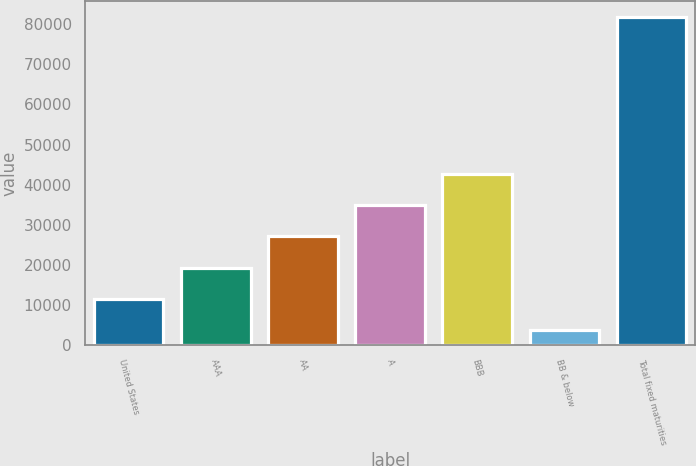<chart> <loc_0><loc_0><loc_500><loc_500><bar_chart><fcel>United States<fcel>AAA<fcel>AA<fcel>A<fcel>BBB<fcel>BB & below<fcel>Total fixed maturities<nl><fcel>11488.4<fcel>19301.8<fcel>27115.2<fcel>34928.6<fcel>42742<fcel>3675<fcel>81809<nl></chart> 